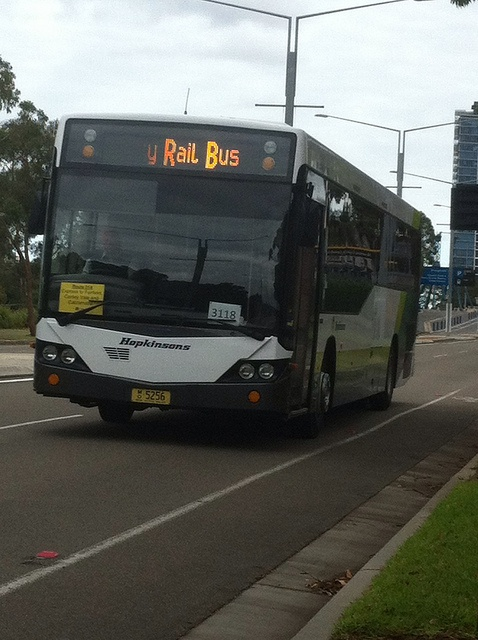Describe the objects in this image and their specific colors. I can see bus in white, black, gray, and purple tones and people in white, black, and purple tones in this image. 